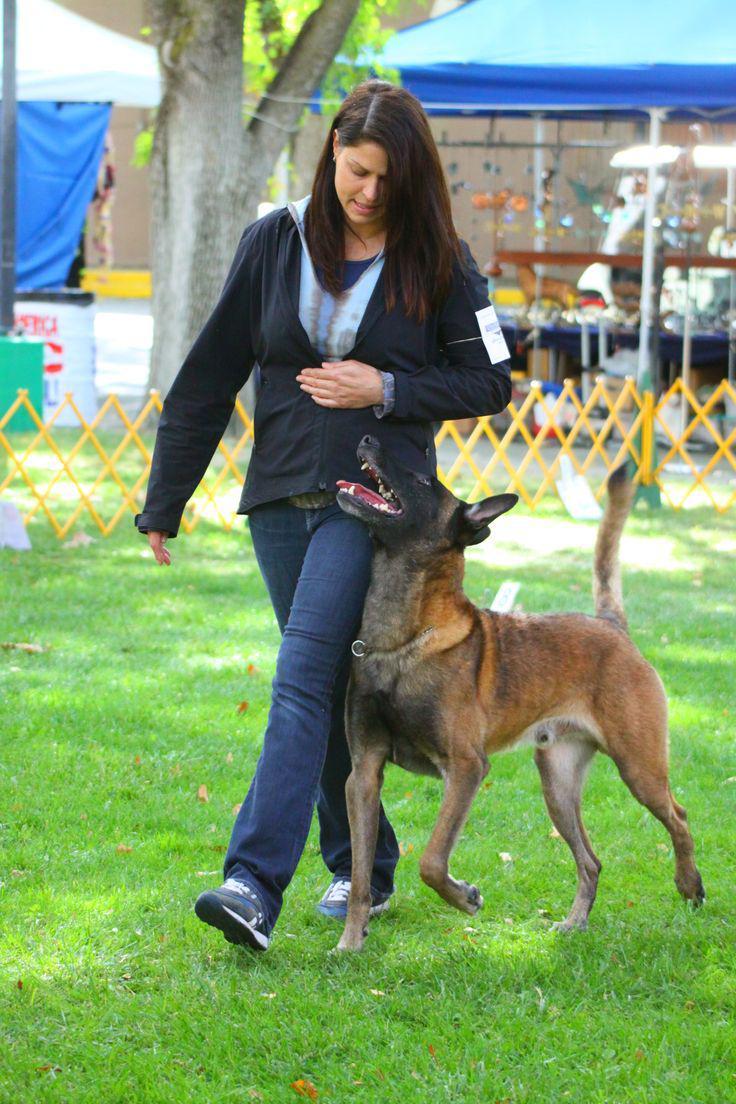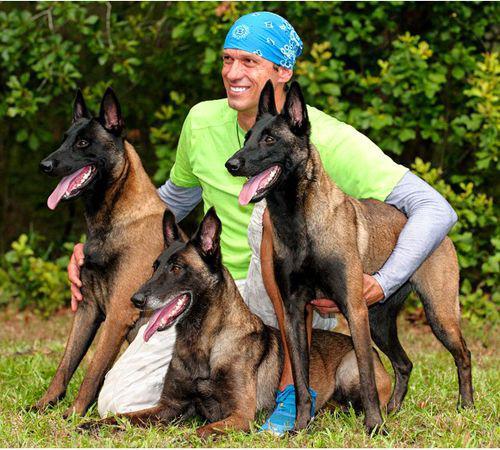The first image is the image on the left, the second image is the image on the right. Considering the images on both sides, is "At least one person appears in each image." valid? Answer yes or no. Yes. 